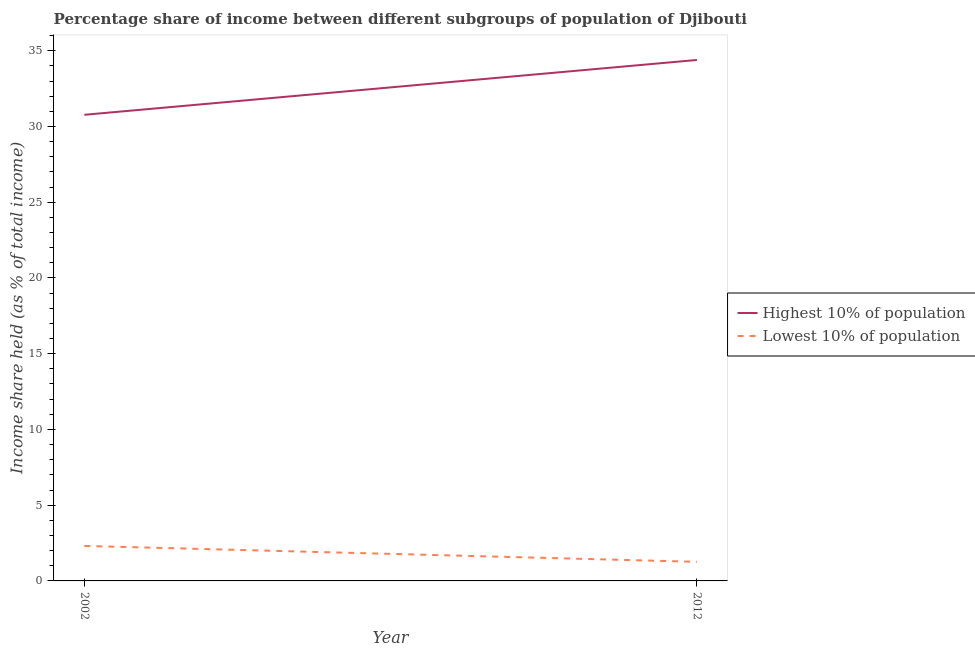How many different coloured lines are there?
Your answer should be compact. 2. Is the number of lines equal to the number of legend labels?
Offer a very short reply. Yes. What is the income share held by lowest 10% of the population in 2012?
Make the answer very short. 1.26. Across all years, what is the maximum income share held by lowest 10% of the population?
Your response must be concise. 2.31. Across all years, what is the minimum income share held by lowest 10% of the population?
Keep it short and to the point. 1.26. In which year was the income share held by lowest 10% of the population minimum?
Provide a succinct answer. 2012. What is the total income share held by lowest 10% of the population in the graph?
Make the answer very short. 3.57. What is the difference between the income share held by highest 10% of the population in 2002 and that in 2012?
Your response must be concise. -3.62. What is the difference between the income share held by lowest 10% of the population in 2012 and the income share held by highest 10% of the population in 2002?
Provide a short and direct response. -29.51. What is the average income share held by highest 10% of the population per year?
Your answer should be very brief. 32.58. In the year 2012, what is the difference between the income share held by highest 10% of the population and income share held by lowest 10% of the population?
Keep it short and to the point. 33.13. What is the ratio of the income share held by lowest 10% of the population in 2002 to that in 2012?
Offer a terse response. 1.83. In how many years, is the income share held by lowest 10% of the population greater than the average income share held by lowest 10% of the population taken over all years?
Offer a terse response. 1. Is the income share held by highest 10% of the population strictly greater than the income share held by lowest 10% of the population over the years?
Offer a very short reply. Yes. How many years are there in the graph?
Your answer should be very brief. 2. What is the difference between two consecutive major ticks on the Y-axis?
Ensure brevity in your answer.  5. Are the values on the major ticks of Y-axis written in scientific E-notation?
Provide a succinct answer. No. Where does the legend appear in the graph?
Your answer should be very brief. Center right. How are the legend labels stacked?
Your answer should be very brief. Vertical. What is the title of the graph?
Give a very brief answer. Percentage share of income between different subgroups of population of Djibouti. What is the label or title of the Y-axis?
Keep it short and to the point. Income share held (as % of total income). What is the Income share held (as % of total income) in Highest 10% of population in 2002?
Your answer should be compact. 30.77. What is the Income share held (as % of total income) of Lowest 10% of population in 2002?
Make the answer very short. 2.31. What is the Income share held (as % of total income) of Highest 10% of population in 2012?
Ensure brevity in your answer.  34.39. What is the Income share held (as % of total income) in Lowest 10% of population in 2012?
Offer a terse response. 1.26. Across all years, what is the maximum Income share held (as % of total income) of Highest 10% of population?
Make the answer very short. 34.39. Across all years, what is the maximum Income share held (as % of total income) in Lowest 10% of population?
Provide a short and direct response. 2.31. Across all years, what is the minimum Income share held (as % of total income) of Highest 10% of population?
Give a very brief answer. 30.77. Across all years, what is the minimum Income share held (as % of total income) in Lowest 10% of population?
Ensure brevity in your answer.  1.26. What is the total Income share held (as % of total income) of Highest 10% of population in the graph?
Offer a very short reply. 65.16. What is the total Income share held (as % of total income) in Lowest 10% of population in the graph?
Provide a succinct answer. 3.57. What is the difference between the Income share held (as % of total income) in Highest 10% of population in 2002 and that in 2012?
Give a very brief answer. -3.62. What is the difference between the Income share held (as % of total income) in Highest 10% of population in 2002 and the Income share held (as % of total income) in Lowest 10% of population in 2012?
Offer a terse response. 29.51. What is the average Income share held (as % of total income) in Highest 10% of population per year?
Your answer should be very brief. 32.58. What is the average Income share held (as % of total income) of Lowest 10% of population per year?
Provide a succinct answer. 1.78. In the year 2002, what is the difference between the Income share held (as % of total income) of Highest 10% of population and Income share held (as % of total income) of Lowest 10% of population?
Ensure brevity in your answer.  28.46. In the year 2012, what is the difference between the Income share held (as % of total income) in Highest 10% of population and Income share held (as % of total income) in Lowest 10% of population?
Make the answer very short. 33.13. What is the ratio of the Income share held (as % of total income) in Highest 10% of population in 2002 to that in 2012?
Give a very brief answer. 0.89. What is the ratio of the Income share held (as % of total income) of Lowest 10% of population in 2002 to that in 2012?
Your response must be concise. 1.83. What is the difference between the highest and the second highest Income share held (as % of total income) of Highest 10% of population?
Provide a succinct answer. 3.62. What is the difference between the highest and the lowest Income share held (as % of total income) of Highest 10% of population?
Your answer should be very brief. 3.62. What is the difference between the highest and the lowest Income share held (as % of total income) of Lowest 10% of population?
Provide a succinct answer. 1.05. 